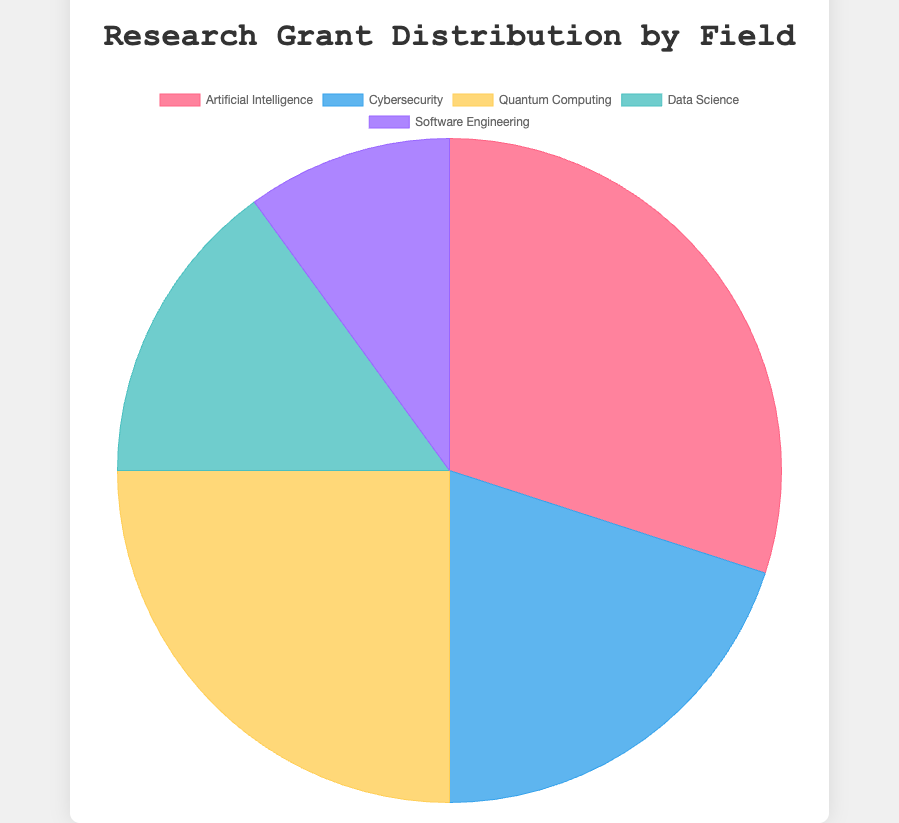What's the largest funding percentage in the chart? By looking at the pie chart and the labels, we can see that "Artificial Intelligence" has the largest funding percentage with 30% of total grants.
Answer: 30% Which field has the smallest slice in the pie chart? By examining the pie chart slices, "Software Engineering" has the smallest slice, representing 10% of the total grants.
Answer: Software Engineering How much larger is the funding percentage for Quantum Computing compared to Data Science? The funding percentage for Quantum Computing is 25%, and for Data Science, it is 15%. Subtracting these values gives us 25% - 15% = 10%.
Answer: 10% What's the total funding percentage for AI and Cybersecurity combined? The funding percentage for AI is 30% and for Cybersecurity it is 20%. Adding these two percentages together gives 30% + 20% = 50%.
Answer: 50% Which field ranks second in terms of funding percentage? In the pie chart, the second largest percentage is for "Quantum Computing" at 25%.
Answer: Quantum Computing What is the most visually prominent color in the pie chart? The largest slice (which is for Artificial Intelligence) is colored in red, making it the most visually prominent color.
Answer: Red How many fields contribute to at least 15% of the total grants? By looking at the percentages in the pie chart for each field, "Artificial Intelligence" (30%), "Cybersecurity" (20%), and "Quantum Computing" (25%) contribute 15% or more. Thus, 3 fields contribute at least 15%.
Answer: 3 If you combine the funding for Cybersecurity and Quantum Computing, which single field would still have a higher funding percentage than their combined total? Cybersecurity (20%) + Quantum Computing (25%) = 45%. No single field has a higher funding percentage than their combined total of 45%.
Answer: None Which fields have funding percentages that are equal? Among the fields listed in the pie chart, none of them have the same funding percentage.
Answer: None What fraction of the pie chart is taken by Data Science and Software Engineering together? Data Science takes 15% and Software Engineering takes 10%. Combining these gives 15% + 10% = 25%, which is a quarter of the pie chart.
Answer: 1/4 